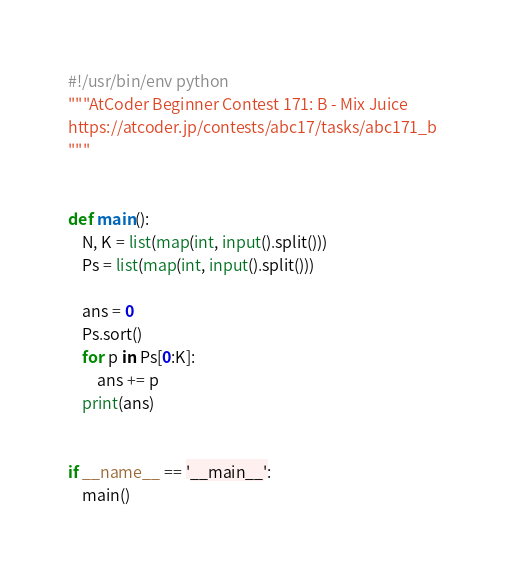Convert code to text. <code><loc_0><loc_0><loc_500><loc_500><_Python_>#!/usr/bin/env python
"""AtCoder Beginner Contest 171: B - Mix Juice
https://atcoder.jp/contests/abc17/tasks/abc171_b
"""


def main():
    N, K = list(map(int, input().split()))
    Ps = list(map(int, input().split()))

    ans = 0
    Ps.sort()
    for p in Ps[0:K]:
        ans += p
    print(ans)


if __name__ == '__main__':
    main()
</code> 